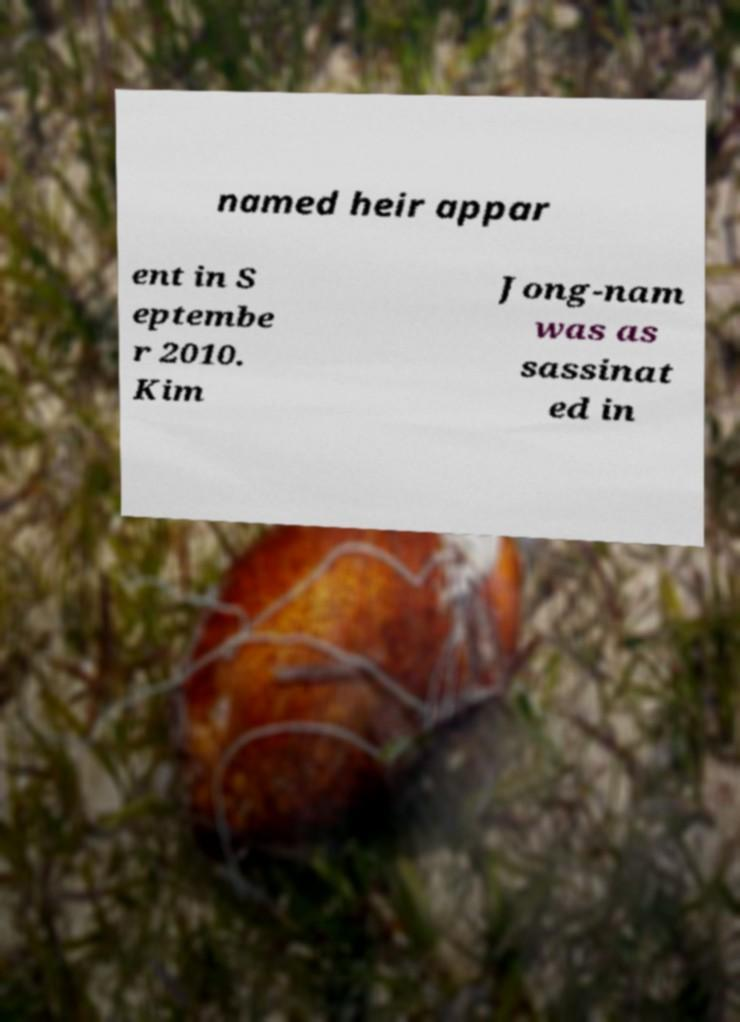Could you extract and type out the text from this image? named heir appar ent in S eptembe r 2010. Kim Jong-nam was as sassinat ed in 